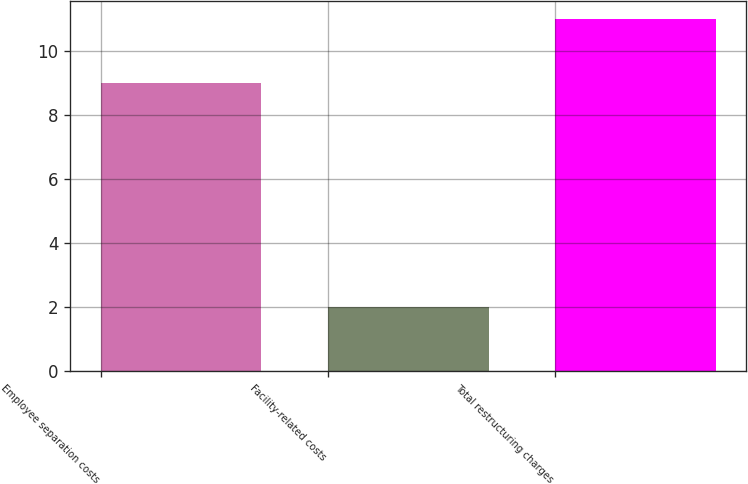Convert chart. <chart><loc_0><loc_0><loc_500><loc_500><bar_chart><fcel>Employee separation costs<fcel>Facility-related costs<fcel>Total restructuring charges<nl><fcel>9<fcel>2<fcel>11<nl></chart> 